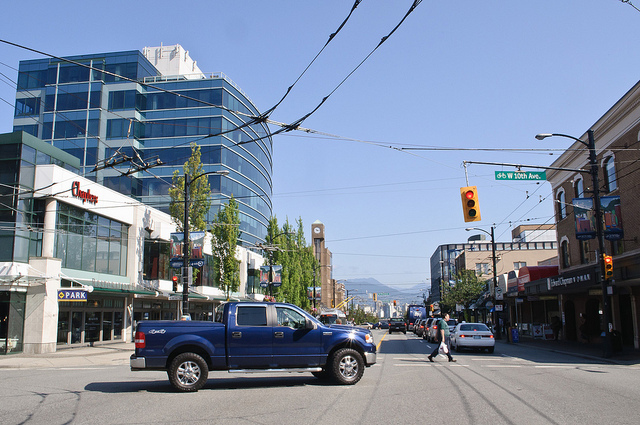Identify the text contained in this image. PARK 10th 